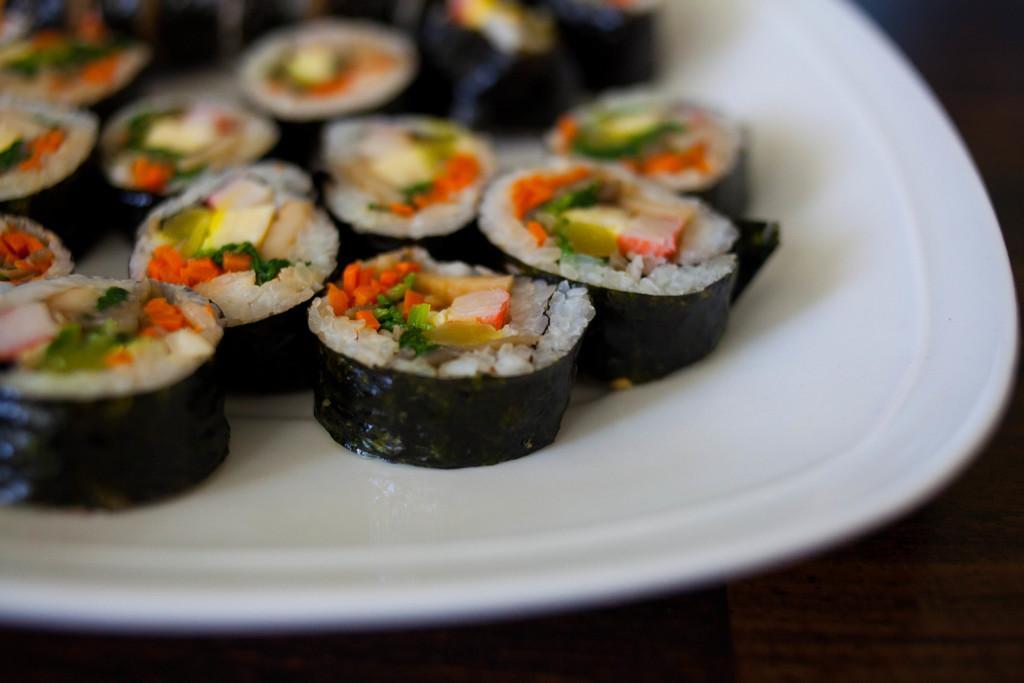How would you summarize this image in a sentence or two? In this picture there is a food on the white plate. 